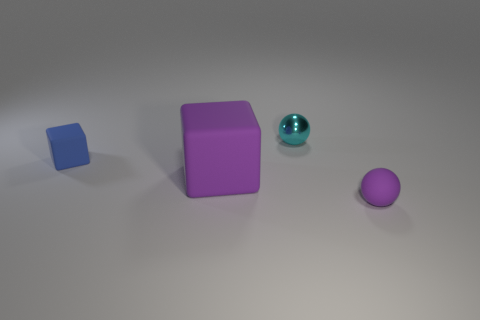Add 1 tiny shiny spheres. How many objects exist? 5 Add 4 tiny rubber things. How many tiny rubber things exist? 6 Subtract 0 purple cylinders. How many objects are left? 4 Subtract all large brown shiny cubes. Subtract all small cubes. How many objects are left? 3 Add 2 tiny cyan metal objects. How many tiny cyan metal objects are left? 3 